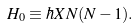Convert formula to latex. <formula><loc_0><loc_0><loc_500><loc_500>H _ { 0 } \equiv \hbar { X } N ( N - 1 ) .</formula> 